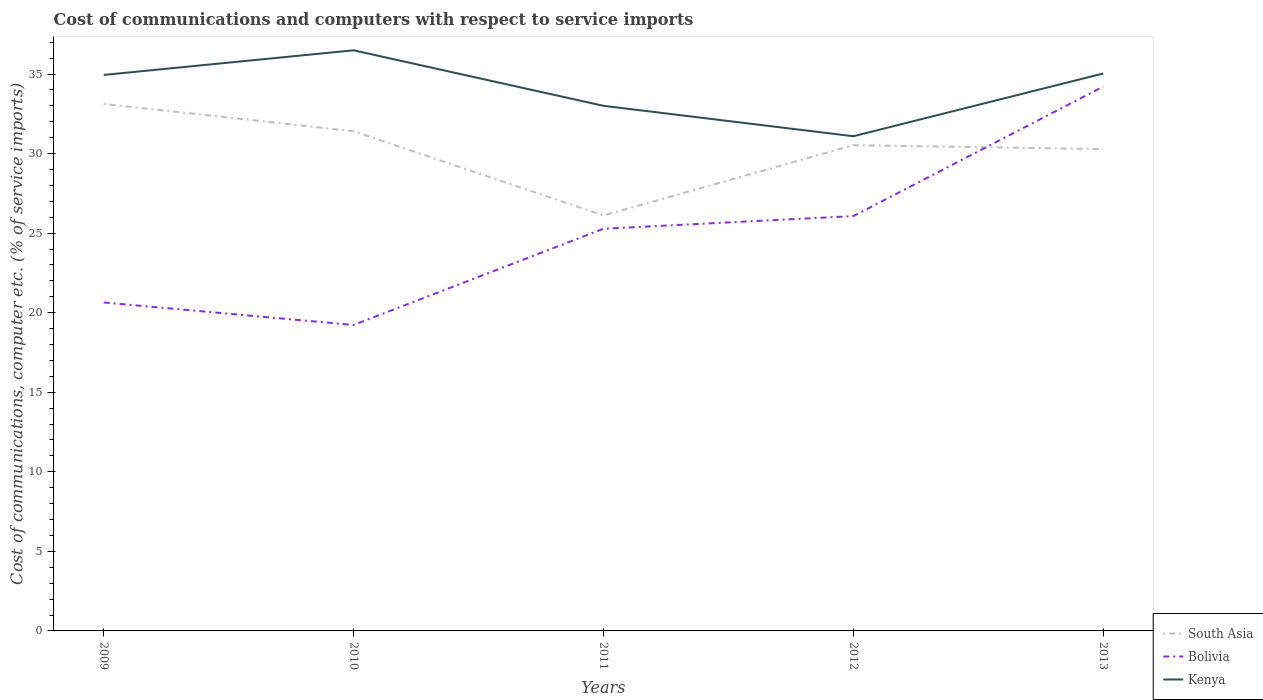Does the line corresponding to Bolivia intersect with the line corresponding to South Asia?
Provide a succinct answer. Yes. Is the number of lines equal to the number of legend labels?
Keep it short and to the point. Yes. Across all years, what is the maximum cost of communications and computers in Bolivia?
Keep it short and to the point. 19.23. In which year was the cost of communications and computers in Bolivia maximum?
Make the answer very short. 2010. What is the total cost of communications and computers in Bolivia in the graph?
Give a very brief answer. -6.05. What is the difference between the highest and the second highest cost of communications and computers in South Asia?
Your response must be concise. 7.01. What is the difference between the highest and the lowest cost of communications and computers in Bolivia?
Keep it short and to the point. 3. Is the cost of communications and computers in South Asia strictly greater than the cost of communications and computers in Bolivia over the years?
Make the answer very short. No. Are the values on the major ticks of Y-axis written in scientific E-notation?
Provide a short and direct response. No. Does the graph contain grids?
Your answer should be compact. No. How are the legend labels stacked?
Ensure brevity in your answer.  Vertical. What is the title of the graph?
Your answer should be very brief. Cost of communications and computers with respect to service imports. Does "High income: nonOECD" appear as one of the legend labels in the graph?
Provide a short and direct response. No. What is the label or title of the X-axis?
Your answer should be very brief. Years. What is the label or title of the Y-axis?
Your answer should be compact. Cost of communications, computer etc. (% of service imports). What is the Cost of communications, computer etc. (% of service imports) in South Asia in 2009?
Your answer should be compact. 33.12. What is the Cost of communications, computer etc. (% of service imports) of Bolivia in 2009?
Offer a very short reply. 20.64. What is the Cost of communications, computer etc. (% of service imports) in Kenya in 2009?
Your response must be concise. 34.94. What is the Cost of communications, computer etc. (% of service imports) of South Asia in 2010?
Keep it short and to the point. 31.4. What is the Cost of communications, computer etc. (% of service imports) in Bolivia in 2010?
Offer a very short reply. 19.23. What is the Cost of communications, computer etc. (% of service imports) in Kenya in 2010?
Provide a short and direct response. 36.49. What is the Cost of communications, computer etc. (% of service imports) of South Asia in 2011?
Keep it short and to the point. 26.11. What is the Cost of communications, computer etc. (% of service imports) of Bolivia in 2011?
Provide a short and direct response. 25.28. What is the Cost of communications, computer etc. (% of service imports) in Kenya in 2011?
Your answer should be compact. 33. What is the Cost of communications, computer etc. (% of service imports) in South Asia in 2012?
Your answer should be very brief. 30.53. What is the Cost of communications, computer etc. (% of service imports) in Bolivia in 2012?
Make the answer very short. 26.07. What is the Cost of communications, computer etc. (% of service imports) of Kenya in 2012?
Make the answer very short. 31.09. What is the Cost of communications, computer etc. (% of service imports) of South Asia in 2013?
Provide a short and direct response. 30.28. What is the Cost of communications, computer etc. (% of service imports) in Bolivia in 2013?
Your answer should be very brief. 34.21. What is the Cost of communications, computer etc. (% of service imports) of Kenya in 2013?
Give a very brief answer. 35.03. Across all years, what is the maximum Cost of communications, computer etc. (% of service imports) in South Asia?
Keep it short and to the point. 33.12. Across all years, what is the maximum Cost of communications, computer etc. (% of service imports) of Bolivia?
Offer a terse response. 34.21. Across all years, what is the maximum Cost of communications, computer etc. (% of service imports) of Kenya?
Make the answer very short. 36.49. Across all years, what is the minimum Cost of communications, computer etc. (% of service imports) in South Asia?
Your answer should be very brief. 26.11. Across all years, what is the minimum Cost of communications, computer etc. (% of service imports) in Bolivia?
Offer a terse response. 19.23. Across all years, what is the minimum Cost of communications, computer etc. (% of service imports) of Kenya?
Make the answer very short. 31.09. What is the total Cost of communications, computer etc. (% of service imports) in South Asia in the graph?
Provide a short and direct response. 151.45. What is the total Cost of communications, computer etc. (% of service imports) of Bolivia in the graph?
Keep it short and to the point. 125.43. What is the total Cost of communications, computer etc. (% of service imports) of Kenya in the graph?
Give a very brief answer. 170.56. What is the difference between the Cost of communications, computer etc. (% of service imports) of South Asia in 2009 and that in 2010?
Ensure brevity in your answer.  1.72. What is the difference between the Cost of communications, computer etc. (% of service imports) in Bolivia in 2009 and that in 2010?
Keep it short and to the point. 1.41. What is the difference between the Cost of communications, computer etc. (% of service imports) of Kenya in 2009 and that in 2010?
Offer a terse response. -1.55. What is the difference between the Cost of communications, computer etc. (% of service imports) of South Asia in 2009 and that in 2011?
Keep it short and to the point. 7.01. What is the difference between the Cost of communications, computer etc. (% of service imports) in Bolivia in 2009 and that in 2011?
Provide a succinct answer. -4.63. What is the difference between the Cost of communications, computer etc. (% of service imports) of Kenya in 2009 and that in 2011?
Provide a short and direct response. 1.94. What is the difference between the Cost of communications, computer etc. (% of service imports) in South Asia in 2009 and that in 2012?
Ensure brevity in your answer.  2.59. What is the difference between the Cost of communications, computer etc. (% of service imports) in Bolivia in 2009 and that in 2012?
Offer a terse response. -5.43. What is the difference between the Cost of communications, computer etc. (% of service imports) of Kenya in 2009 and that in 2012?
Provide a succinct answer. 3.85. What is the difference between the Cost of communications, computer etc. (% of service imports) of South Asia in 2009 and that in 2013?
Make the answer very short. 2.84. What is the difference between the Cost of communications, computer etc. (% of service imports) in Bolivia in 2009 and that in 2013?
Make the answer very short. -13.57. What is the difference between the Cost of communications, computer etc. (% of service imports) in Kenya in 2009 and that in 2013?
Give a very brief answer. -0.09. What is the difference between the Cost of communications, computer etc. (% of service imports) of South Asia in 2010 and that in 2011?
Your answer should be very brief. 5.29. What is the difference between the Cost of communications, computer etc. (% of service imports) of Bolivia in 2010 and that in 2011?
Your answer should be very brief. -6.05. What is the difference between the Cost of communications, computer etc. (% of service imports) of Kenya in 2010 and that in 2011?
Make the answer very short. 3.49. What is the difference between the Cost of communications, computer etc. (% of service imports) of South Asia in 2010 and that in 2012?
Make the answer very short. 0.88. What is the difference between the Cost of communications, computer etc. (% of service imports) in Bolivia in 2010 and that in 2012?
Your answer should be very brief. -6.84. What is the difference between the Cost of communications, computer etc. (% of service imports) in Kenya in 2010 and that in 2012?
Provide a succinct answer. 5.4. What is the difference between the Cost of communications, computer etc. (% of service imports) in South Asia in 2010 and that in 2013?
Provide a succinct answer. 1.12. What is the difference between the Cost of communications, computer etc. (% of service imports) in Bolivia in 2010 and that in 2013?
Your answer should be compact. -14.98. What is the difference between the Cost of communications, computer etc. (% of service imports) in Kenya in 2010 and that in 2013?
Give a very brief answer. 1.46. What is the difference between the Cost of communications, computer etc. (% of service imports) of South Asia in 2011 and that in 2012?
Your response must be concise. -4.42. What is the difference between the Cost of communications, computer etc. (% of service imports) in Bolivia in 2011 and that in 2012?
Your answer should be very brief. -0.79. What is the difference between the Cost of communications, computer etc. (% of service imports) of Kenya in 2011 and that in 2012?
Your response must be concise. 1.91. What is the difference between the Cost of communications, computer etc. (% of service imports) in South Asia in 2011 and that in 2013?
Keep it short and to the point. -4.17. What is the difference between the Cost of communications, computer etc. (% of service imports) in Bolivia in 2011 and that in 2013?
Provide a succinct answer. -8.94. What is the difference between the Cost of communications, computer etc. (% of service imports) of Kenya in 2011 and that in 2013?
Ensure brevity in your answer.  -2.03. What is the difference between the Cost of communications, computer etc. (% of service imports) in South Asia in 2012 and that in 2013?
Your response must be concise. 0.25. What is the difference between the Cost of communications, computer etc. (% of service imports) in Bolivia in 2012 and that in 2013?
Provide a succinct answer. -8.14. What is the difference between the Cost of communications, computer etc. (% of service imports) of Kenya in 2012 and that in 2013?
Make the answer very short. -3.94. What is the difference between the Cost of communications, computer etc. (% of service imports) in South Asia in 2009 and the Cost of communications, computer etc. (% of service imports) in Bolivia in 2010?
Make the answer very short. 13.89. What is the difference between the Cost of communications, computer etc. (% of service imports) in South Asia in 2009 and the Cost of communications, computer etc. (% of service imports) in Kenya in 2010?
Keep it short and to the point. -3.37. What is the difference between the Cost of communications, computer etc. (% of service imports) of Bolivia in 2009 and the Cost of communications, computer etc. (% of service imports) of Kenya in 2010?
Your answer should be very brief. -15.85. What is the difference between the Cost of communications, computer etc. (% of service imports) of South Asia in 2009 and the Cost of communications, computer etc. (% of service imports) of Bolivia in 2011?
Your answer should be compact. 7.85. What is the difference between the Cost of communications, computer etc. (% of service imports) of South Asia in 2009 and the Cost of communications, computer etc. (% of service imports) of Kenya in 2011?
Offer a terse response. 0.12. What is the difference between the Cost of communications, computer etc. (% of service imports) in Bolivia in 2009 and the Cost of communications, computer etc. (% of service imports) in Kenya in 2011?
Give a very brief answer. -12.36. What is the difference between the Cost of communications, computer etc. (% of service imports) of South Asia in 2009 and the Cost of communications, computer etc. (% of service imports) of Bolivia in 2012?
Offer a very short reply. 7.05. What is the difference between the Cost of communications, computer etc. (% of service imports) of South Asia in 2009 and the Cost of communications, computer etc. (% of service imports) of Kenya in 2012?
Provide a short and direct response. 2.03. What is the difference between the Cost of communications, computer etc. (% of service imports) in Bolivia in 2009 and the Cost of communications, computer etc. (% of service imports) in Kenya in 2012?
Your answer should be compact. -10.45. What is the difference between the Cost of communications, computer etc. (% of service imports) of South Asia in 2009 and the Cost of communications, computer etc. (% of service imports) of Bolivia in 2013?
Offer a very short reply. -1.09. What is the difference between the Cost of communications, computer etc. (% of service imports) in South Asia in 2009 and the Cost of communications, computer etc. (% of service imports) in Kenya in 2013?
Give a very brief answer. -1.91. What is the difference between the Cost of communications, computer etc. (% of service imports) in Bolivia in 2009 and the Cost of communications, computer etc. (% of service imports) in Kenya in 2013?
Offer a terse response. -14.39. What is the difference between the Cost of communications, computer etc. (% of service imports) in South Asia in 2010 and the Cost of communications, computer etc. (% of service imports) in Bolivia in 2011?
Provide a short and direct response. 6.13. What is the difference between the Cost of communications, computer etc. (% of service imports) in South Asia in 2010 and the Cost of communications, computer etc. (% of service imports) in Kenya in 2011?
Keep it short and to the point. -1.6. What is the difference between the Cost of communications, computer etc. (% of service imports) in Bolivia in 2010 and the Cost of communications, computer etc. (% of service imports) in Kenya in 2011?
Keep it short and to the point. -13.77. What is the difference between the Cost of communications, computer etc. (% of service imports) in South Asia in 2010 and the Cost of communications, computer etc. (% of service imports) in Bolivia in 2012?
Offer a terse response. 5.33. What is the difference between the Cost of communications, computer etc. (% of service imports) of South Asia in 2010 and the Cost of communications, computer etc. (% of service imports) of Kenya in 2012?
Give a very brief answer. 0.32. What is the difference between the Cost of communications, computer etc. (% of service imports) in Bolivia in 2010 and the Cost of communications, computer etc. (% of service imports) in Kenya in 2012?
Your answer should be very brief. -11.86. What is the difference between the Cost of communications, computer etc. (% of service imports) of South Asia in 2010 and the Cost of communications, computer etc. (% of service imports) of Bolivia in 2013?
Give a very brief answer. -2.81. What is the difference between the Cost of communications, computer etc. (% of service imports) in South Asia in 2010 and the Cost of communications, computer etc. (% of service imports) in Kenya in 2013?
Give a very brief answer. -3.63. What is the difference between the Cost of communications, computer etc. (% of service imports) of Bolivia in 2010 and the Cost of communications, computer etc. (% of service imports) of Kenya in 2013?
Give a very brief answer. -15.81. What is the difference between the Cost of communications, computer etc. (% of service imports) of South Asia in 2011 and the Cost of communications, computer etc. (% of service imports) of Bolivia in 2012?
Keep it short and to the point. 0.04. What is the difference between the Cost of communications, computer etc. (% of service imports) of South Asia in 2011 and the Cost of communications, computer etc. (% of service imports) of Kenya in 2012?
Your answer should be compact. -4.98. What is the difference between the Cost of communications, computer etc. (% of service imports) of Bolivia in 2011 and the Cost of communications, computer etc. (% of service imports) of Kenya in 2012?
Give a very brief answer. -5.81. What is the difference between the Cost of communications, computer etc. (% of service imports) in South Asia in 2011 and the Cost of communications, computer etc. (% of service imports) in Bolivia in 2013?
Provide a succinct answer. -8.1. What is the difference between the Cost of communications, computer etc. (% of service imports) in South Asia in 2011 and the Cost of communications, computer etc. (% of service imports) in Kenya in 2013?
Offer a very short reply. -8.92. What is the difference between the Cost of communications, computer etc. (% of service imports) in Bolivia in 2011 and the Cost of communications, computer etc. (% of service imports) in Kenya in 2013?
Provide a short and direct response. -9.76. What is the difference between the Cost of communications, computer etc. (% of service imports) in South Asia in 2012 and the Cost of communications, computer etc. (% of service imports) in Bolivia in 2013?
Ensure brevity in your answer.  -3.69. What is the difference between the Cost of communications, computer etc. (% of service imports) in South Asia in 2012 and the Cost of communications, computer etc. (% of service imports) in Kenya in 2013?
Your answer should be compact. -4.51. What is the difference between the Cost of communications, computer etc. (% of service imports) in Bolivia in 2012 and the Cost of communications, computer etc. (% of service imports) in Kenya in 2013?
Offer a terse response. -8.96. What is the average Cost of communications, computer etc. (% of service imports) of South Asia per year?
Provide a short and direct response. 30.29. What is the average Cost of communications, computer etc. (% of service imports) of Bolivia per year?
Provide a short and direct response. 25.09. What is the average Cost of communications, computer etc. (% of service imports) of Kenya per year?
Provide a succinct answer. 34.11. In the year 2009, what is the difference between the Cost of communications, computer etc. (% of service imports) of South Asia and Cost of communications, computer etc. (% of service imports) of Bolivia?
Offer a terse response. 12.48. In the year 2009, what is the difference between the Cost of communications, computer etc. (% of service imports) of South Asia and Cost of communications, computer etc. (% of service imports) of Kenya?
Your answer should be very brief. -1.82. In the year 2009, what is the difference between the Cost of communications, computer etc. (% of service imports) in Bolivia and Cost of communications, computer etc. (% of service imports) in Kenya?
Your answer should be very brief. -14.3. In the year 2010, what is the difference between the Cost of communications, computer etc. (% of service imports) of South Asia and Cost of communications, computer etc. (% of service imports) of Bolivia?
Offer a very short reply. 12.18. In the year 2010, what is the difference between the Cost of communications, computer etc. (% of service imports) in South Asia and Cost of communications, computer etc. (% of service imports) in Kenya?
Your response must be concise. -5.09. In the year 2010, what is the difference between the Cost of communications, computer etc. (% of service imports) of Bolivia and Cost of communications, computer etc. (% of service imports) of Kenya?
Your answer should be compact. -17.26. In the year 2011, what is the difference between the Cost of communications, computer etc. (% of service imports) of South Asia and Cost of communications, computer etc. (% of service imports) of Bolivia?
Offer a very short reply. 0.84. In the year 2011, what is the difference between the Cost of communications, computer etc. (% of service imports) of South Asia and Cost of communications, computer etc. (% of service imports) of Kenya?
Provide a succinct answer. -6.89. In the year 2011, what is the difference between the Cost of communications, computer etc. (% of service imports) of Bolivia and Cost of communications, computer etc. (% of service imports) of Kenya?
Your answer should be very brief. -7.73. In the year 2012, what is the difference between the Cost of communications, computer etc. (% of service imports) of South Asia and Cost of communications, computer etc. (% of service imports) of Bolivia?
Your answer should be very brief. 4.46. In the year 2012, what is the difference between the Cost of communications, computer etc. (% of service imports) of South Asia and Cost of communications, computer etc. (% of service imports) of Kenya?
Give a very brief answer. -0.56. In the year 2012, what is the difference between the Cost of communications, computer etc. (% of service imports) of Bolivia and Cost of communications, computer etc. (% of service imports) of Kenya?
Your answer should be very brief. -5.02. In the year 2013, what is the difference between the Cost of communications, computer etc. (% of service imports) in South Asia and Cost of communications, computer etc. (% of service imports) in Bolivia?
Offer a very short reply. -3.93. In the year 2013, what is the difference between the Cost of communications, computer etc. (% of service imports) in South Asia and Cost of communications, computer etc. (% of service imports) in Kenya?
Your answer should be compact. -4.75. In the year 2013, what is the difference between the Cost of communications, computer etc. (% of service imports) of Bolivia and Cost of communications, computer etc. (% of service imports) of Kenya?
Your answer should be compact. -0.82. What is the ratio of the Cost of communications, computer etc. (% of service imports) of South Asia in 2009 to that in 2010?
Your answer should be very brief. 1.05. What is the ratio of the Cost of communications, computer etc. (% of service imports) of Bolivia in 2009 to that in 2010?
Provide a short and direct response. 1.07. What is the ratio of the Cost of communications, computer etc. (% of service imports) in Kenya in 2009 to that in 2010?
Give a very brief answer. 0.96. What is the ratio of the Cost of communications, computer etc. (% of service imports) of South Asia in 2009 to that in 2011?
Provide a short and direct response. 1.27. What is the ratio of the Cost of communications, computer etc. (% of service imports) of Bolivia in 2009 to that in 2011?
Offer a very short reply. 0.82. What is the ratio of the Cost of communications, computer etc. (% of service imports) of Kenya in 2009 to that in 2011?
Offer a terse response. 1.06. What is the ratio of the Cost of communications, computer etc. (% of service imports) in South Asia in 2009 to that in 2012?
Give a very brief answer. 1.08. What is the ratio of the Cost of communications, computer etc. (% of service imports) in Bolivia in 2009 to that in 2012?
Keep it short and to the point. 0.79. What is the ratio of the Cost of communications, computer etc. (% of service imports) in Kenya in 2009 to that in 2012?
Make the answer very short. 1.12. What is the ratio of the Cost of communications, computer etc. (% of service imports) in South Asia in 2009 to that in 2013?
Make the answer very short. 1.09. What is the ratio of the Cost of communications, computer etc. (% of service imports) in Bolivia in 2009 to that in 2013?
Offer a terse response. 0.6. What is the ratio of the Cost of communications, computer etc. (% of service imports) in South Asia in 2010 to that in 2011?
Your answer should be compact. 1.2. What is the ratio of the Cost of communications, computer etc. (% of service imports) of Bolivia in 2010 to that in 2011?
Your answer should be very brief. 0.76. What is the ratio of the Cost of communications, computer etc. (% of service imports) in Kenya in 2010 to that in 2011?
Your answer should be very brief. 1.11. What is the ratio of the Cost of communications, computer etc. (% of service imports) in South Asia in 2010 to that in 2012?
Provide a short and direct response. 1.03. What is the ratio of the Cost of communications, computer etc. (% of service imports) in Bolivia in 2010 to that in 2012?
Offer a very short reply. 0.74. What is the ratio of the Cost of communications, computer etc. (% of service imports) of Kenya in 2010 to that in 2012?
Provide a short and direct response. 1.17. What is the ratio of the Cost of communications, computer etc. (% of service imports) of South Asia in 2010 to that in 2013?
Keep it short and to the point. 1.04. What is the ratio of the Cost of communications, computer etc. (% of service imports) of Bolivia in 2010 to that in 2013?
Your answer should be very brief. 0.56. What is the ratio of the Cost of communications, computer etc. (% of service imports) of Kenya in 2010 to that in 2013?
Make the answer very short. 1.04. What is the ratio of the Cost of communications, computer etc. (% of service imports) in South Asia in 2011 to that in 2012?
Your answer should be compact. 0.86. What is the ratio of the Cost of communications, computer etc. (% of service imports) of Bolivia in 2011 to that in 2012?
Make the answer very short. 0.97. What is the ratio of the Cost of communications, computer etc. (% of service imports) in Kenya in 2011 to that in 2012?
Provide a succinct answer. 1.06. What is the ratio of the Cost of communications, computer etc. (% of service imports) in South Asia in 2011 to that in 2013?
Offer a terse response. 0.86. What is the ratio of the Cost of communications, computer etc. (% of service imports) in Bolivia in 2011 to that in 2013?
Your response must be concise. 0.74. What is the ratio of the Cost of communications, computer etc. (% of service imports) in Kenya in 2011 to that in 2013?
Make the answer very short. 0.94. What is the ratio of the Cost of communications, computer etc. (% of service imports) in Bolivia in 2012 to that in 2013?
Give a very brief answer. 0.76. What is the ratio of the Cost of communications, computer etc. (% of service imports) in Kenya in 2012 to that in 2013?
Ensure brevity in your answer.  0.89. What is the difference between the highest and the second highest Cost of communications, computer etc. (% of service imports) in South Asia?
Make the answer very short. 1.72. What is the difference between the highest and the second highest Cost of communications, computer etc. (% of service imports) in Bolivia?
Offer a terse response. 8.14. What is the difference between the highest and the second highest Cost of communications, computer etc. (% of service imports) of Kenya?
Make the answer very short. 1.46. What is the difference between the highest and the lowest Cost of communications, computer etc. (% of service imports) in South Asia?
Your answer should be compact. 7.01. What is the difference between the highest and the lowest Cost of communications, computer etc. (% of service imports) of Bolivia?
Offer a terse response. 14.98. What is the difference between the highest and the lowest Cost of communications, computer etc. (% of service imports) in Kenya?
Your answer should be compact. 5.4. 